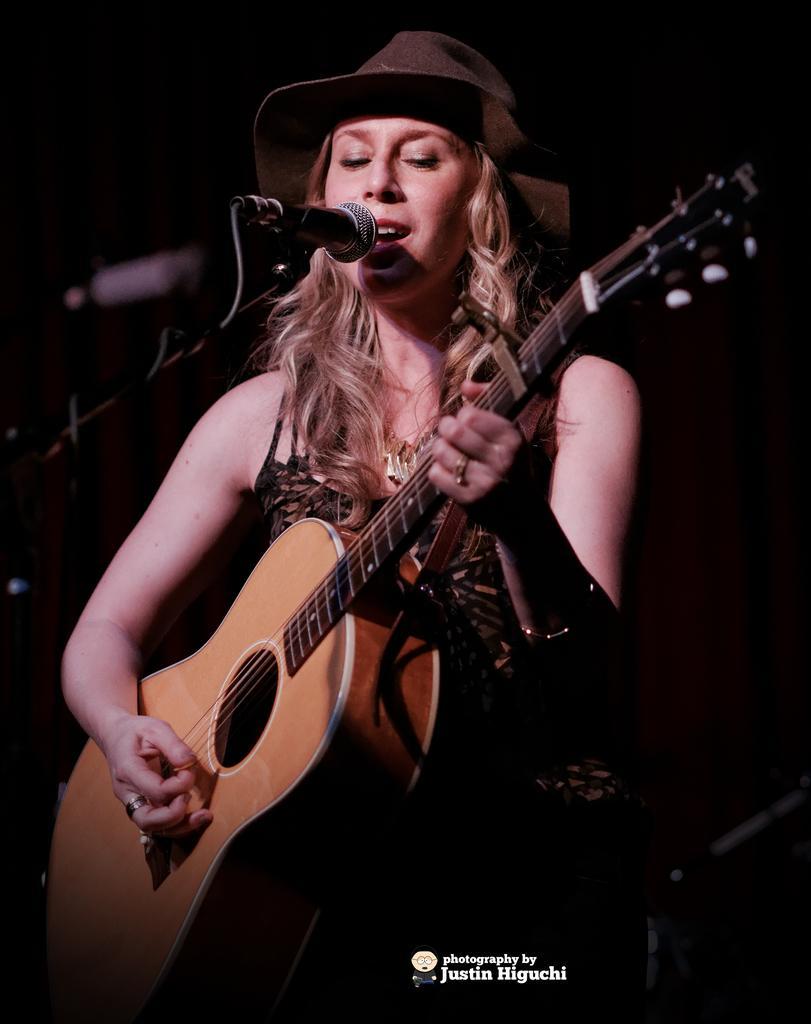Can you describe this image briefly? In this image I can see a person is in-front of the mic and holding the guitar. 